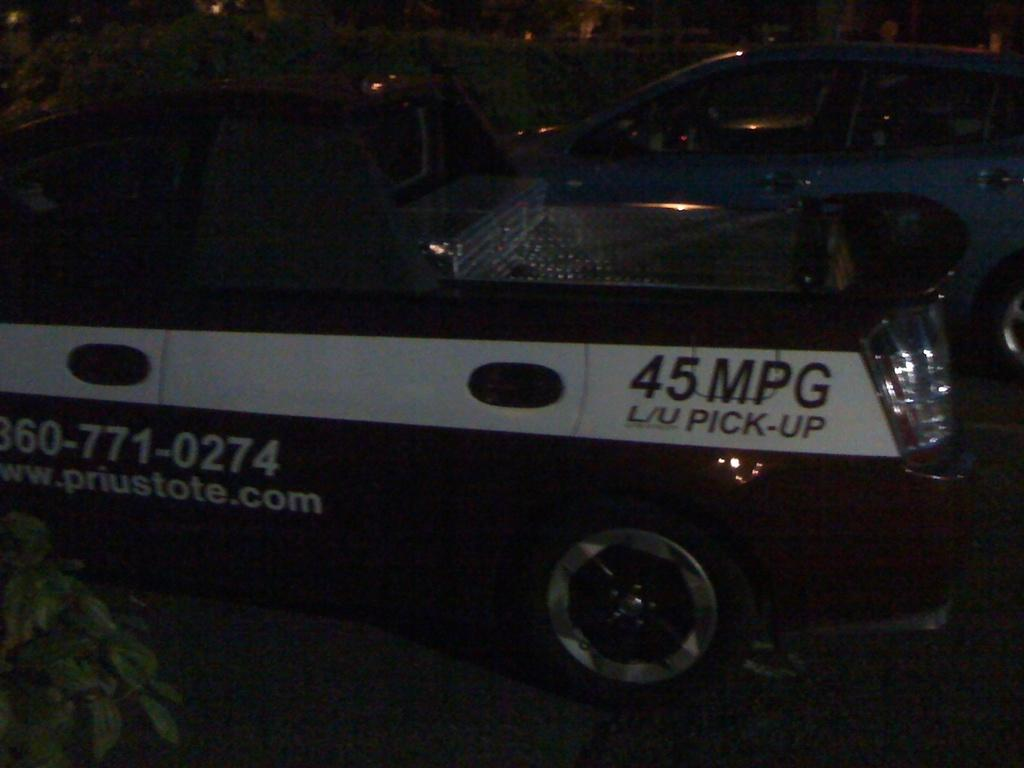What can be seen in the image? There are vehicles in the image. Can you describe any specific details about the vehicles? There is text visible on at least one vehicle. What else is present in the image besides the vehicles? There is a plant at the bottom left side of the image. How would you describe the overall appearance of the image? The background of the image is dark. What type of notebook is being used by the plant in the image? There is no notebook present in the image, and the plant is not using any apparel or accessories. 